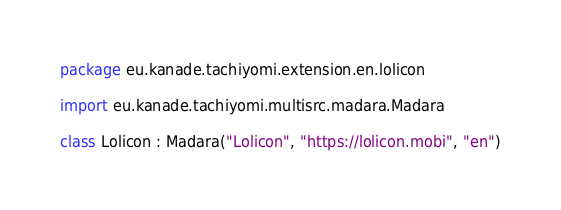<code> <loc_0><loc_0><loc_500><loc_500><_Kotlin_>package eu.kanade.tachiyomi.extension.en.lolicon

import eu.kanade.tachiyomi.multisrc.madara.Madara

class Lolicon : Madara("Lolicon", "https://lolicon.mobi", "en")
</code> 